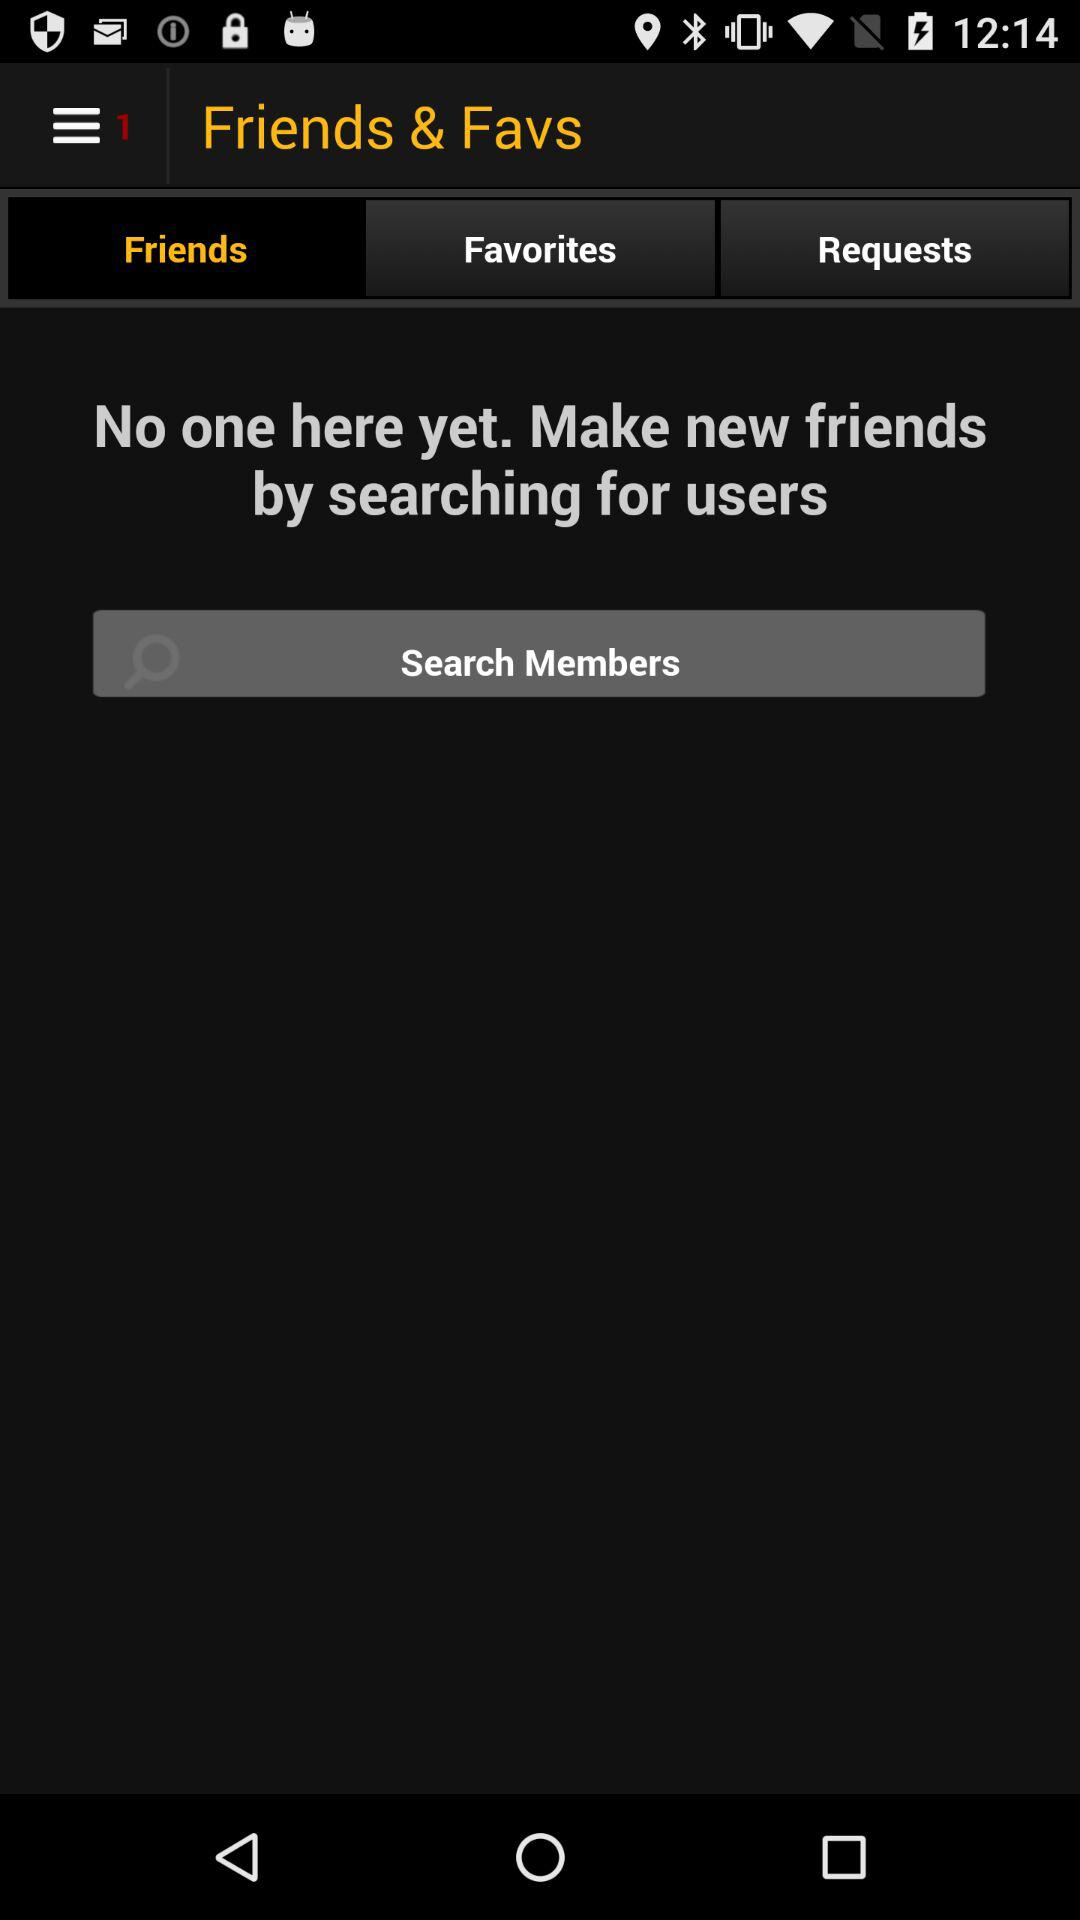What is the selected option? The selected option is "Friends". 